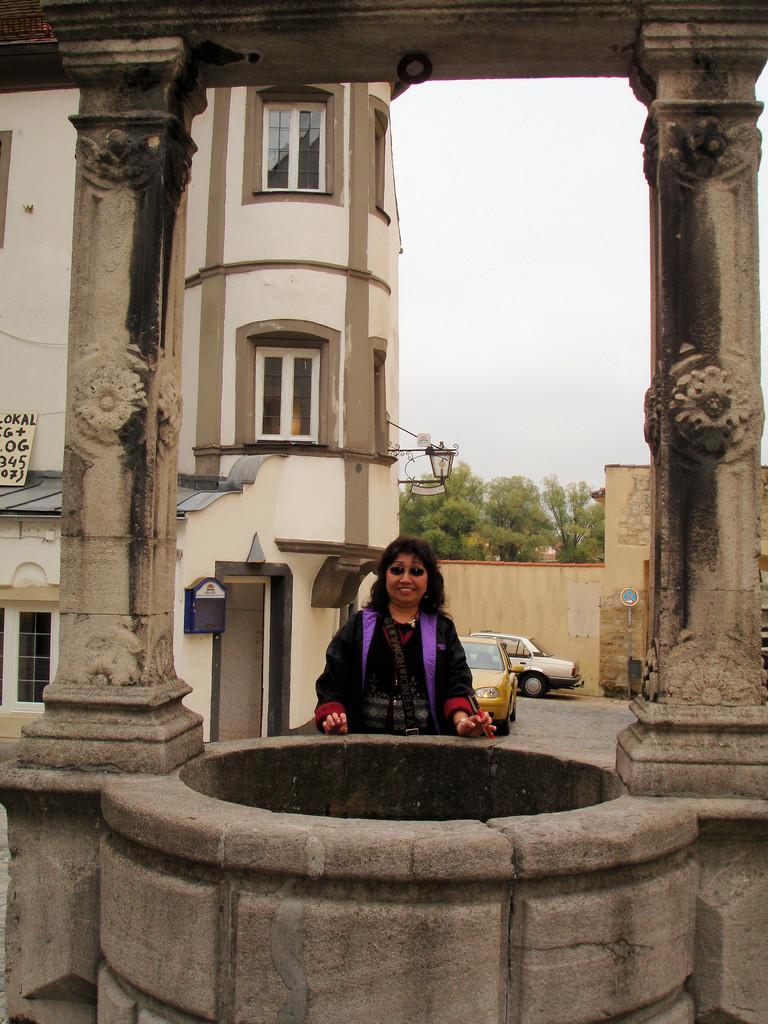Can you describe this image briefly? This image is taken outdoors. At the bottom of the image there is a well and there are two pillars with a roof. In the middle of the image a woman is standing on the ground, and two cars are parked on the ground. On the left side of the image there is a building with a few walls, windows and a door. In the background there are a few trees and there is a sky. 